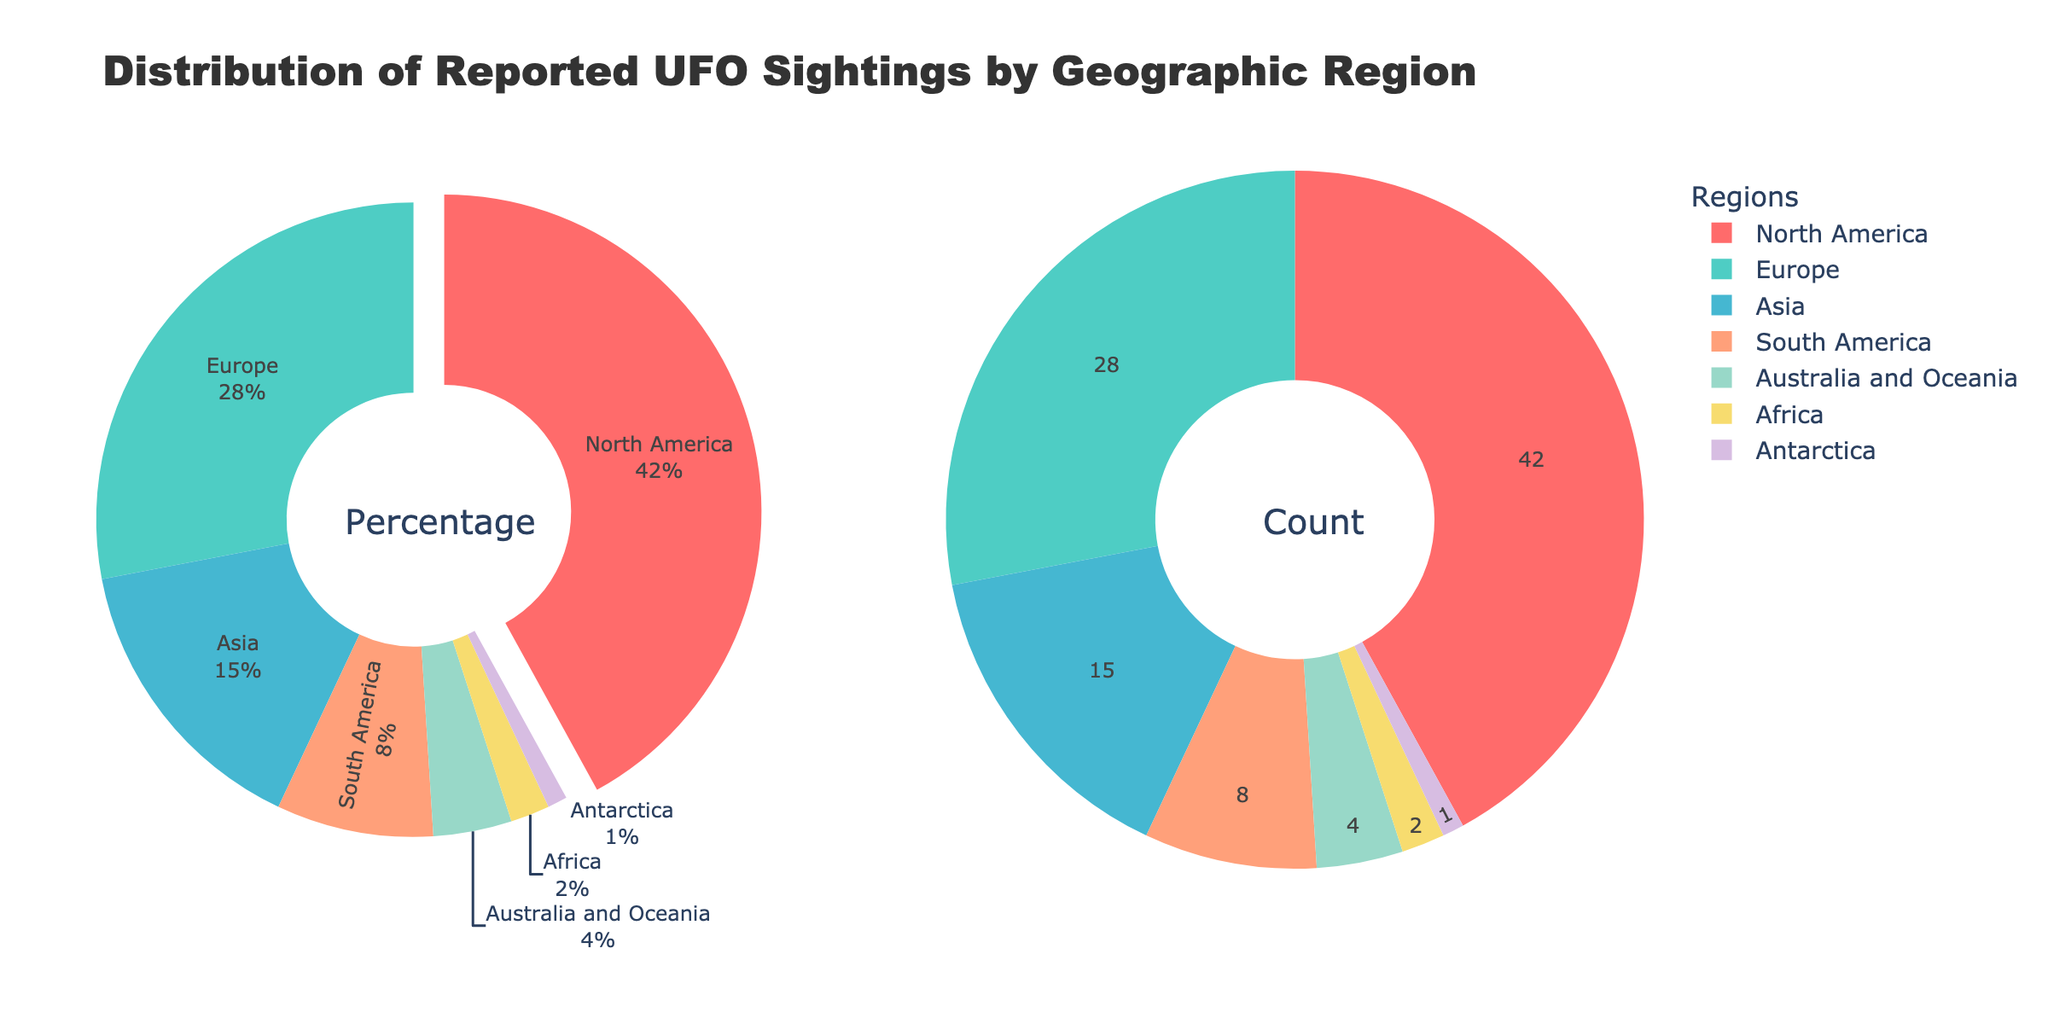What's the title of the figure? The title is written at the top of the figure and provides an overview of what the figure represents.
Answer: Distribution of Reported UFO Sightings by Geographic Region What are the regions represented in the pie charts? The regions can be identified by looking at the labels or the legend in the pie charts.
Answer: North America, Europe, Asia, South America, Australia and Oceania, Africa, Antarctica Which region has the highest percentage of reported UFO sightings? Look for the largest slice in the pie chart labeled with the percentage information.
Answer: North America What is the percentage of reported UFO sightings in Europe and Asia combined? Find the percentage of Europe (28%) and Asia (15%) in the pie chart and add them together: 28% + 15%.
Answer: 43% Which regions have less than 5% of reported UFO sightings? Identify the slices in the pie chart with percentage information less than 5%.
Answer: Australia and Oceania, Africa, Antarctica How much larger is the percentage of sightings in North America compared to South America? Subtract the percentage of South America (8%) from North America (42%): 42% - 8%.
Answer: 34% If the total number of sightings globally is 10,000, how many sightings were reported in Africa? Convert the percentage of Africa (2%) to a number by multiplying by the total sightings: 2/100 * 10,000.
Answer: 200 Which regions are represented by the colors in both pie charts? Identify the legend or color-coded regions from the pie charts.
Answer: North America, Europe, Asia, South America, Australia and Oceania, Africa, Antarctica What is the difference in the number of sightings between Europe and Antarctica if the total number of sightings is 10,000? Convert the percentages to numbers (Europe: 28/100 * 10,000 = 2800; Antarctica: 1/100 * 10,000 = 100), then subtract: 2800 - 100.
Answer: 2700 How many regions are represented in the pie charts? Count the number of unique labels or slices in the pie chart.
Answer: 7 